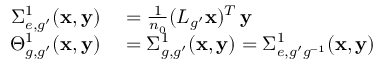<formula> <loc_0><loc_0><loc_500><loc_500>\begin{array} { r l } { \Sigma _ { e , g ^ { \prime } } ^ { 1 } ( \mathbf x , \mathbf y ) } & = \frac { 1 } { n _ { 0 } } ( L _ { g ^ { \prime } } x ) ^ { T } \, y } \\ { \Theta _ { g , g ^ { \prime } } ^ { 1 } ( \mathbf x , \mathbf y ) } & = \Sigma _ { g , g ^ { \prime } } ^ { 1 } ( \mathbf x , \mathbf y ) = \Sigma _ { e , g ^ { \prime } g ^ { - 1 } } ^ { 1 } ( \mathbf x , \mathbf y ) } \end{array}</formula> 